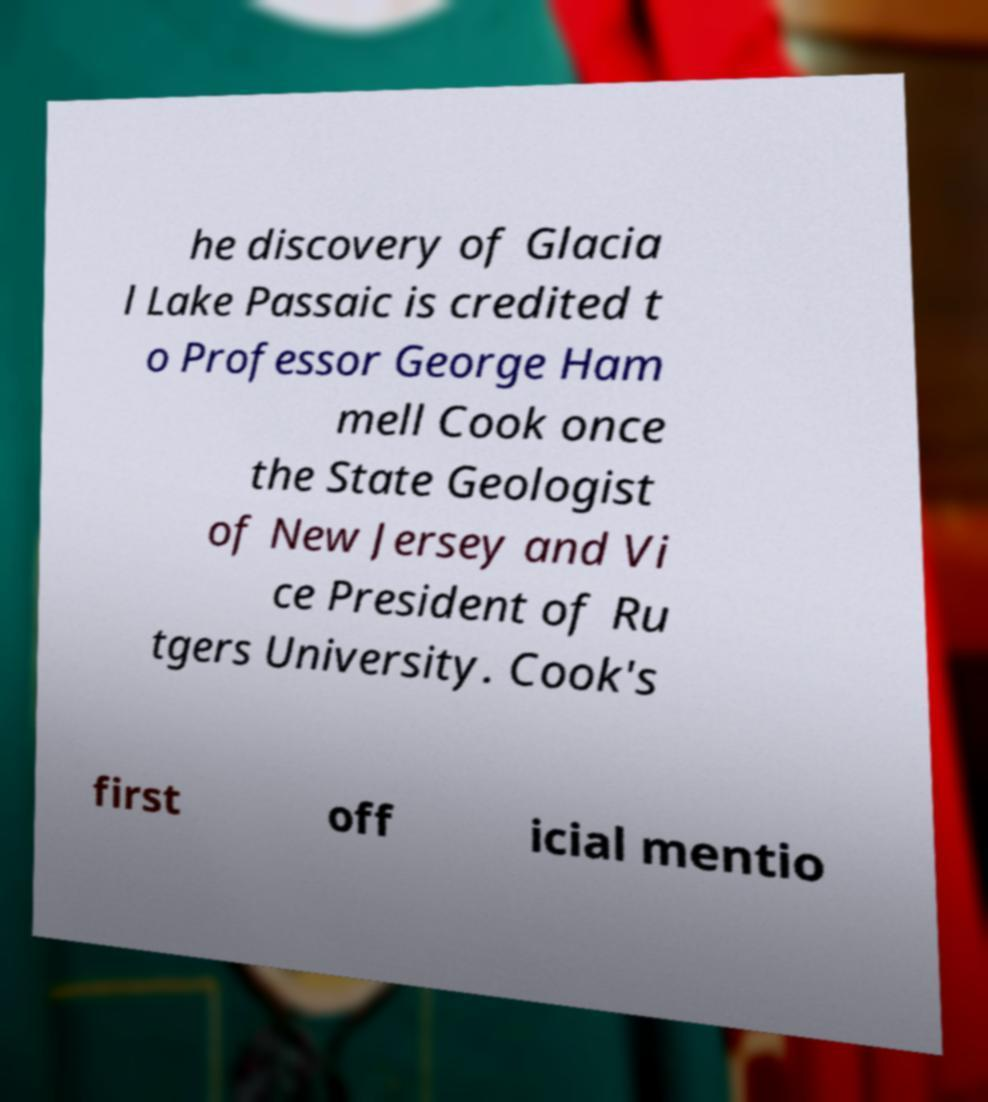I need the written content from this picture converted into text. Can you do that? he discovery of Glacia l Lake Passaic is credited t o Professor George Ham mell Cook once the State Geologist of New Jersey and Vi ce President of Ru tgers University. Cook's first off icial mentio 